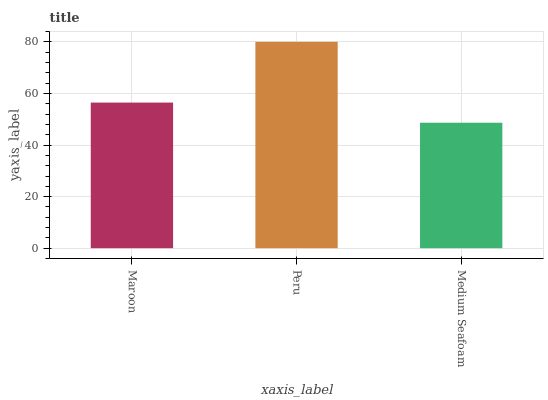Is Medium Seafoam the minimum?
Answer yes or no. Yes. Is Peru the maximum?
Answer yes or no. Yes. Is Peru the minimum?
Answer yes or no. No. Is Medium Seafoam the maximum?
Answer yes or no. No. Is Peru greater than Medium Seafoam?
Answer yes or no. Yes. Is Medium Seafoam less than Peru?
Answer yes or no. Yes. Is Medium Seafoam greater than Peru?
Answer yes or no. No. Is Peru less than Medium Seafoam?
Answer yes or no. No. Is Maroon the high median?
Answer yes or no. Yes. Is Maroon the low median?
Answer yes or no. Yes. Is Medium Seafoam the high median?
Answer yes or no. No. Is Peru the low median?
Answer yes or no. No. 